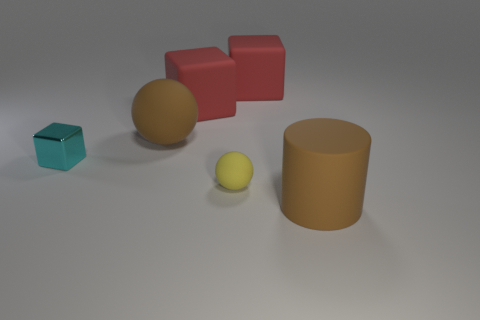Does the brown thing that is behind the tiny cyan metallic thing have the same shape as the small rubber thing?
Ensure brevity in your answer.  Yes. Does the matte cylinder have the same size as the yellow thing?
Your answer should be compact. No. How many things are either large rubber things behind the brown cylinder or small spheres?
Provide a succinct answer. 4. How many other things are the same size as the cylinder?
Offer a very short reply. 3. What color is the small block?
Provide a short and direct response. Cyan. What number of big objects are yellow spheres or red objects?
Offer a terse response. 2. There is a red thing to the right of the tiny yellow matte object; does it have the same size as the yellow matte thing that is behind the brown cylinder?
Your answer should be compact. No. Are there more red rubber blocks that are on the right side of the small cyan object than big things that are on the left side of the big brown rubber ball?
Give a very brief answer. Yes. The thing that is in front of the brown rubber ball and behind the tiny rubber object is made of what material?
Offer a very short reply. Metal. What color is the other big thing that is the same shape as the yellow rubber object?
Keep it short and to the point. Brown. 